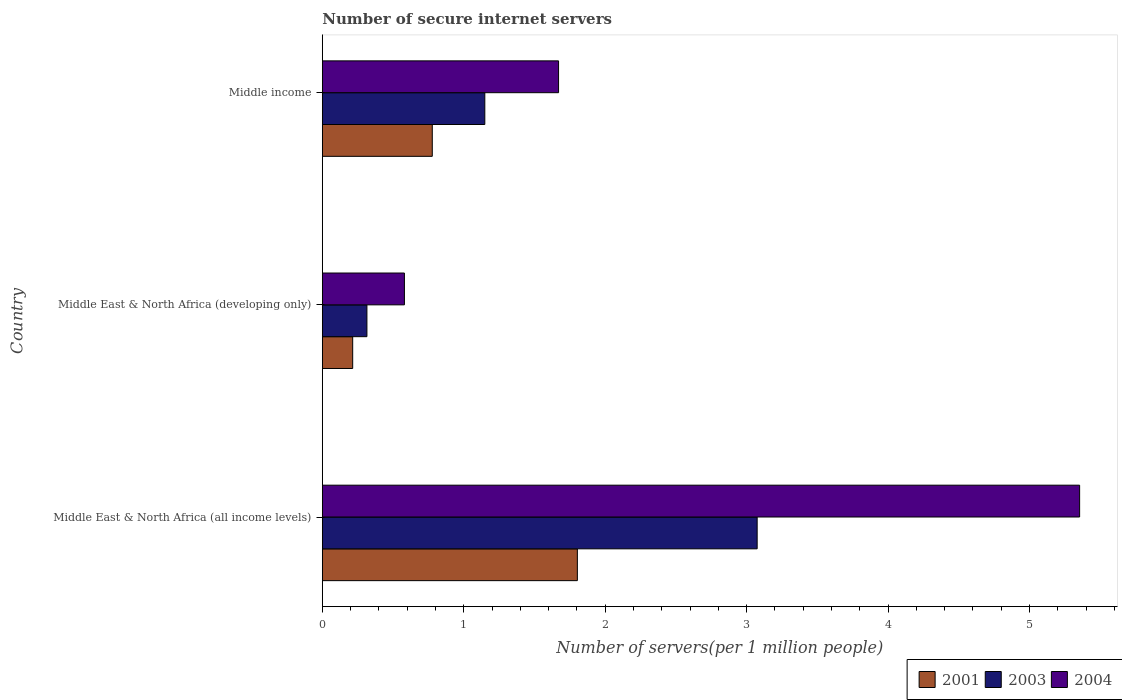Are the number of bars on each tick of the Y-axis equal?
Your response must be concise. Yes. How many bars are there on the 2nd tick from the top?
Offer a very short reply. 3. What is the label of the 2nd group of bars from the top?
Offer a terse response. Middle East & North Africa (developing only). What is the number of secure internet servers in 2004 in Middle East & North Africa (all income levels)?
Provide a succinct answer. 5.35. Across all countries, what is the maximum number of secure internet servers in 2004?
Offer a very short reply. 5.35. Across all countries, what is the minimum number of secure internet servers in 2003?
Offer a very short reply. 0.32. In which country was the number of secure internet servers in 2001 maximum?
Your answer should be compact. Middle East & North Africa (all income levels). In which country was the number of secure internet servers in 2001 minimum?
Your response must be concise. Middle East & North Africa (developing only). What is the total number of secure internet servers in 2001 in the graph?
Your answer should be very brief. 2.8. What is the difference between the number of secure internet servers in 2004 in Middle East & North Africa (developing only) and that in Middle income?
Provide a succinct answer. -1.09. What is the difference between the number of secure internet servers in 2004 in Middle East & North Africa (developing only) and the number of secure internet servers in 2001 in Middle East & North Africa (all income levels)?
Keep it short and to the point. -1.22. What is the average number of secure internet servers in 2004 per country?
Ensure brevity in your answer.  2.53. What is the difference between the number of secure internet servers in 2004 and number of secure internet servers in 2003 in Middle East & North Africa (all income levels)?
Offer a very short reply. 2.28. What is the ratio of the number of secure internet servers in 2003 in Middle East & North Africa (all income levels) to that in Middle income?
Your answer should be very brief. 2.68. Is the number of secure internet servers in 2001 in Middle East & North Africa (all income levels) less than that in Middle income?
Make the answer very short. No. Is the difference between the number of secure internet servers in 2004 in Middle East & North Africa (all income levels) and Middle income greater than the difference between the number of secure internet servers in 2003 in Middle East & North Africa (all income levels) and Middle income?
Provide a succinct answer. Yes. What is the difference between the highest and the second highest number of secure internet servers in 2003?
Provide a succinct answer. 1.93. What is the difference between the highest and the lowest number of secure internet servers in 2003?
Offer a very short reply. 2.76. Is the sum of the number of secure internet servers in 2003 in Middle East & North Africa (all income levels) and Middle income greater than the maximum number of secure internet servers in 2004 across all countries?
Your answer should be compact. No. What does the 1st bar from the top in Middle income represents?
Your response must be concise. 2004. What is the difference between two consecutive major ticks on the X-axis?
Give a very brief answer. 1. Are the values on the major ticks of X-axis written in scientific E-notation?
Make the answer very short. No. Does the graph contain any zero values?
Ensure brevity in your answer.  No. How many legend labels are there?
Your response must be concise. 3. What is the title of the graph?
Provide a short and direct response. Number of secure internet servers. Does "2011" appear as one of the legend labels in the graph?
Make the answer very short. No. What is the label or title of the X-axis?
Your answer should be compact. Number of servers(per 1 million people). What is the label or title of the Y-axis?
Provide a short and direct response. Country. What is the Number of servers(per 1 million people) in 2001 in Middle East & North Africa (all income levels)?
Give a very brief answer. 1.8. What is the Number of servers(per 1 million people) of 2003 in Middle East & North Africa (all income levels)?
Make the answer very short. 3.07. What is the Number of servers(per 1 million people) of 2004 in Middle East & North Africa (all income levels)?
Keep it short and to the point. 5.35. What is the Number of servers(per 1 million people) of 2001 in Middle East & North Africa (developing only)?
Your answer should be very brief. 0.21. What is the Number of servers(per 1 million people) in 2003 in Middle East & North Africa (developing only)?
Your answer should be very brief. 0.32. What is the Number of servers(per 1 million people) of 2004 in Middle East & North Africa (developing only)?
Make the answer very short. 0.58. What is the Number of servers(per 1 million people) in 2001 in Middle income?
Your answer should be very brief. 0.78. What is the Number of servers(per 1 million people) in 2003 in Middle income?
Give a very brief answer. 1.15. What is the Number of servers(per 1 million people) of 2004 in Middle income?
Provide a succinct answer. 1.67. Across all countries, what is the maximum Number of servers(per 1 million people) in 2001?
Keep it short and to the point. 1.8. Across all countries, what is the maximum Number of servers(per 1 million people) of 2003?
Provide a short and direct response. 3.07. Across all countries, what is the maximum Number of servers(per 1 million people) in 2004?
Keep it short and to the point. 5.35. Across all countries, what is the minimum Number of servers(per 1 million people) in 2001?
Your answer should be compact. 0.21. Across all countries, what is the minimum Number of servers(per 1 million people) of 2003?
Your response must be concise. 0.32. Across all countries, what is the minimum Number of servers(per 1 million people) in 2004?
Your response must be concise. 0.58. What is the total Number of servers(per 1 million people) of 2001 in the graph?
Give a very brief answer. 2.8. What is the total Number of servers(per 1 million people) in 2003 in the graph?
Your response must be concise. 4.54. What is the total Number of servers(per 1 million people) of 2004 in the graph?
Provide a short and direct response. 7.61. What is the difference between the Number of servers(per 1 million people) in 2001 in Middle East & North Africa (all income levels) and that in Middle East & North Africa (developing only)?
Provide a short and direct response. 1.59. What is the difference between the Number of servers(per 1 million people) of 2003 in Middle East & North Africa (all income levels) and that in Middle East & North Africa (developing only)?
Your response must be concise. 2.76. What is the difference between the Number of servers(per 1 million people) in 2004 in Middle East & North Africa (all income levels) and that in Middle East & North Africa (developing only)?
Offer a very short reply. 4.77. What is the difference between the Number of servers(per 1 million people) of 2001 in Middle East & North Africa (all income levels) and that in Middle income?
Offer a very short reply. 1.03. What is the difference between the Number of servers(per 1 million people) in 2003 in Middle East & North Africa (all income levels) and that in Middle income?
Provide a succinct answer. 1.93. What is the difference between the Number of servers(per 1 million people) in 2004 in Middle East & North Africa (all income levels) and that in Middle income?
Provide a succinct answer. 3.68. What is the difference between the Number of servers(per 1 million people) of 2001 in Middle East & North Africa (developing only) and that in Middle income?
Your answer should be compact. -0.56. What is the difference between the Number of servers(per 1 million people) of 2003 in Middle East & North Africa (developing only) and that in Middle income?
Offer a very short reply. -0.83. What is the difference between the Number of servers(per 1 million people) in 2004 in Middle East & North Africa (developing only) and that in Middle income?
Your answer should be compact. -1.09. What is the difference between the Number of servers(per 1 million people) of 2001 in Middle East & North Africa (all income levels) and the Number of servers(per 1 million people) of 2003 in Middle East & North Africa (developing only)?
Give a very brief answer. 1.49. What is the difference between the Number of servers(per 1 million people) in 2001 in Middle East & North Africa (all income levels) and the Number of servers(per 1 million people) in 2004 in Middle East & North Africa (developing only)?
Your response must be concise. 1.22. What is the difference between the Number of servers(per 1 million people) of 2003 in Middle East & North Africa (all income levels) and the Number of servers(per 1 million people) of 2004 in Middle East & North Africa (developing only)?
Ensure brevity in your answer.  2.49. What is the difference between the Number of servers(per 1 million people) in 2001 in Middle East & North Africa (all income levels) and the Number of servers(per 1 million people) in 2003 in Middle income?
Make the answer very short. 0.65. What is the difference between the Number of servers(per 1 million people) of 2001 in Middle East & North Africa (all income levels) and the Number of servers(per 1 million people) of 2004 in Middle income?
Make the answer very short. 0.13. What is the difference between the Number of servers(per 1 million people) of 2003 in Middle East & North Africa (all income levels) and the Number of servers(per 1 million people) of 2004 in Middle income?
Ensure brevity in your answer.  1.4. What is the difference between the Number of servers(per 1 million people) in 2001 in Middle East & North Africa (developing only) and the Number of servers(per 1 million people) in 2003 in Middle income?
Make the answer very short. -0.93. What is the difference between the Number of servers(per 1 million people) in 2001 in Middle East & North Africa (developing only) and the Number of servers(per 1 million people) in 2004 in Middle income?
Keep it short and to the point. -1.46. What is the difference between the Number of servers(per 1 million people) in 2003 in Middle East & North Africa (developing only) and the Number of servers(per 1 million people) in 2004 in Middle income?
Provide a short and direct response. -1.35. What is the average Number of servers(per 1 million people) in 2001 per country?
Offer a terse response. 0.93. What is the average Number of servers(per 1 million people) in 2003 per country?
Your answer should be very brief. 1.51. What is the average Number of servers(per 1 million people) in 2004 per country?
Your answer should be very brief. 2.54. What is the difference between the Number of servers(per 1 million people) of 2001 and Number of servers(per 1 million people) of 2003 in Middle East & North Africa (all income levels)?
Ensure brevity in your answer.  -1.27. What is the difference between the Number of servers(per 1 million people) of 2001 and Number of servers(per 1 million people) of 2004 in Middle East & North Africa (all income levels)?
Offer a very short reply. -3.55. What is the difference between the Number of servers(per 1 million people) of 2003 and Number of servers(per 1 million people) of 2004 in Middle East & North Africa (all income levels)?
Provide a succinct answer. -2.28. What is the difference between the Number of servers(per 1 million people) of 2001 and Number of servers(per 1 million people) of 2003 in Middle East & North Africa (developing only)?
Give a very brief answer. -0.1. What is the difference between the Number of servers(per 1 million people) in 2001 and Number of servers(per 1 million people) in 2004 in Middle East & North Africa (developing only)?
Provide a succinct answer. -0.37. What is the difference between the Number of servers(per 1 million people) in 2003 and Number of servers(per 1 million people) in 2004 in Middle East & North Africa (developing only)?
Give a very brief answer. -0.27. What is the difference between the Number of servers(per 1 million people) in 2001 and Number of servers(per 1 million people) in 2003 in Middle income?
Offer a terse response. -0.37. What is the difference between the Number of servers(per 1 million people) in 2001 and Number of servers(per 1 million people) in 2004 in Middle income?
Keep it short and to the point. -0.89. What is the difference between the Number of servers(per 1 million people) of 2003 and Number of servers(per 1 million people) of 2004 in Middle income?
Ensure brevity in your answer.  -0.52. What is the ratio of the Number of servers(per 1 million people) in 2001 in Middle East & North Africa (all income levels) to that in Middle East & North Africa (developing only)?
Keep it short and to the point. 8.4. What is the ratio of the Number of servers(per 1 million people) in 2003 in Middle East & North Africa (all income levels) to that in Middle East & North Africa (developing only)?
Give a very brief answer. 9.75. What is the ratio of the Number of servers(per 1 million people) of 2004 in Middle East & North Africa (all income levels) to that in Middle East & North Africa (developing only)?
Offer a terse response. 9.22. What is the ratio of the Number of servers(per 1 million people) in 2001 in Middle East & North Africa (all income levels) to that in Middle income?
Give a very brief answer. 2.32. What is the ratio of the Number of servers(per 1 million people) in 2003 in Middle East & North Africa (all income levels) to that in Middle income?
Your response must be concise. 2.68. What is the ratio of the Number of servers(per 1 million people) of 2004 in Middle East & North Africa (all income levels) to that in Middle income?
Make the answer very short. 3.21. What is the ratio of the Number of servers(per 1 million people) of 2001 in Middle East & North Africa (developing only) to that in Middle income?
Keep it short and to the point. 0.28. What is the ratio of the Number of servers(per 1 million people) in 2003 in Middle East & North Africa (developing only) to that in Middle income?
Give a very brief answer. 0.27. What is the ratio of the Number of servers(per 1 million people) of 2004 in Middle East & North Africa (developing only) to that in Middle income?
Give a very brief answer. 0.35. What is the difference between the highest and the second highest Number of servers(per 1 million people) of 2001?
Keep it short and to the point. 1.03. What is the difference between the highest and the second highest Number of servers(per 1 million people) in 2003?
Give a very brief answer. 1.93. What is the difference between the highest and the second highest Number of servers(per 1 million people) of 2004?
Your answer should be very brief. 3.68. What is the difference between the highest and the lowest Number of servers(per 1 million people) of 2001?
Ensure brevity in your answer.  1.59. What is the difference between the highest and the lowest Number of servers(per 1 million people) of 2003?
Your response must be concise. 2.76. What is the difference between the highest and the lowest Number of servers(per 1 million people) of 2004?
Keep it short and to the point. 4.77. 